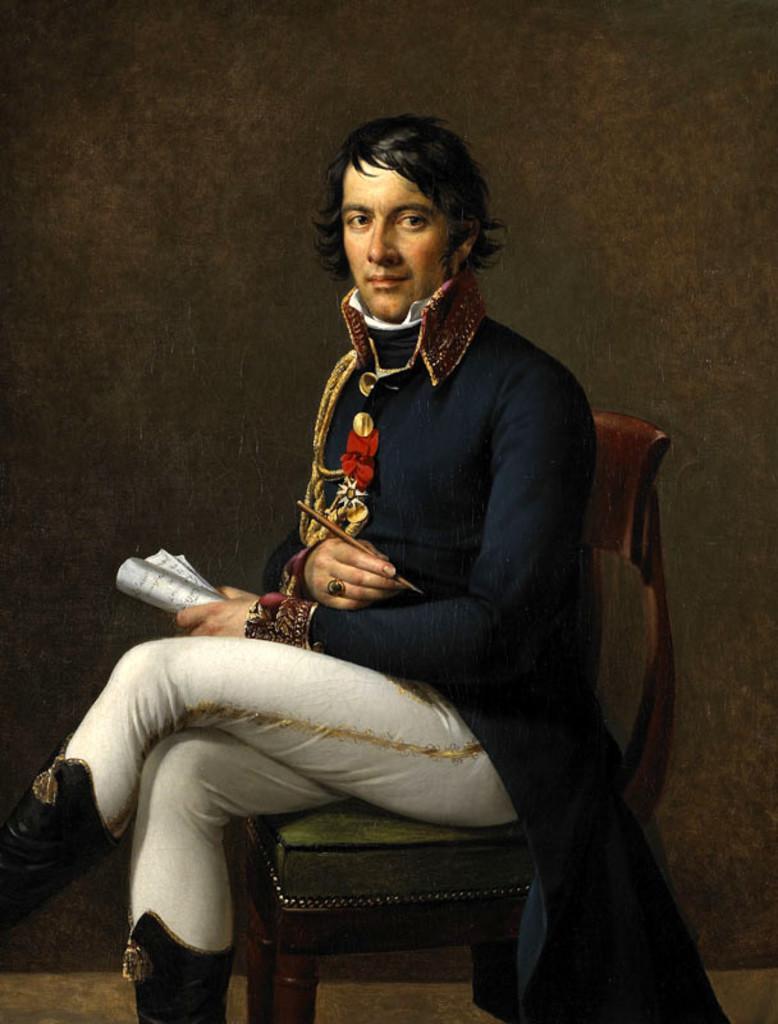How would you summarize this image in a sentence or two? As we can see in the image there is a wall and a person siting on chair. 